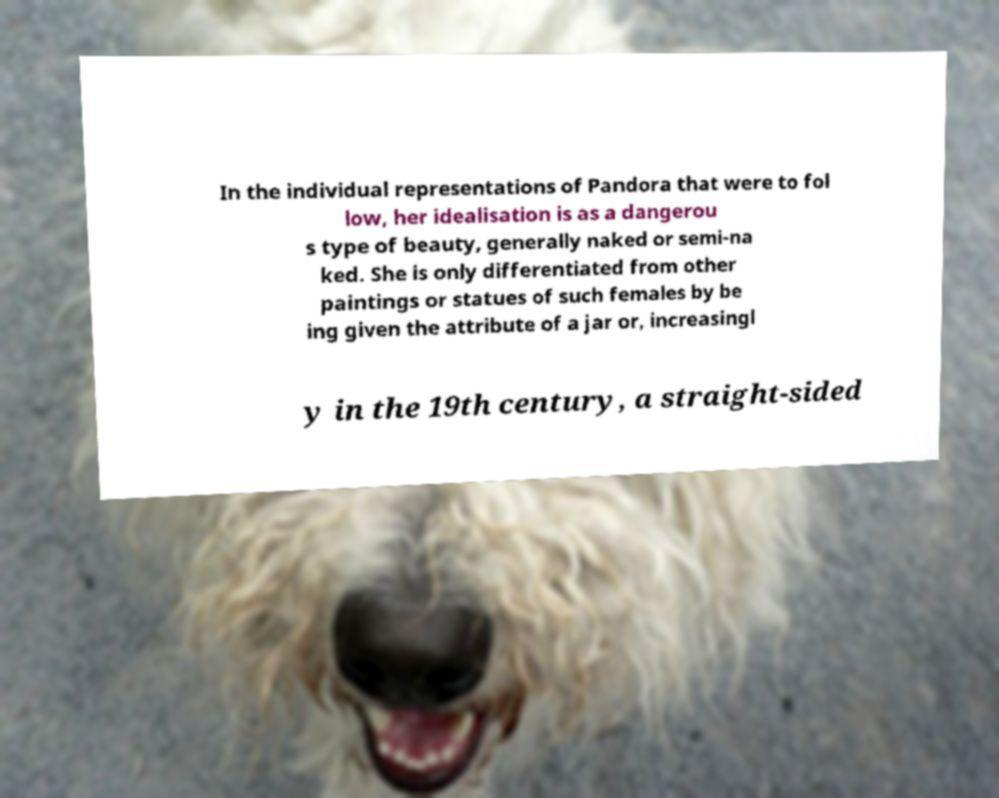I need the written content from this picture converted into text. Can you do that? In the individual representations of Pandora that were to fol low, her idealisation is as a dangerou s type of beauty, generally naked or semi-na ked. She is only differentiated from other paintings or statues of such females by be ing given the attribute of a jar or, increasingl y in the 19th century, a straight-sided 